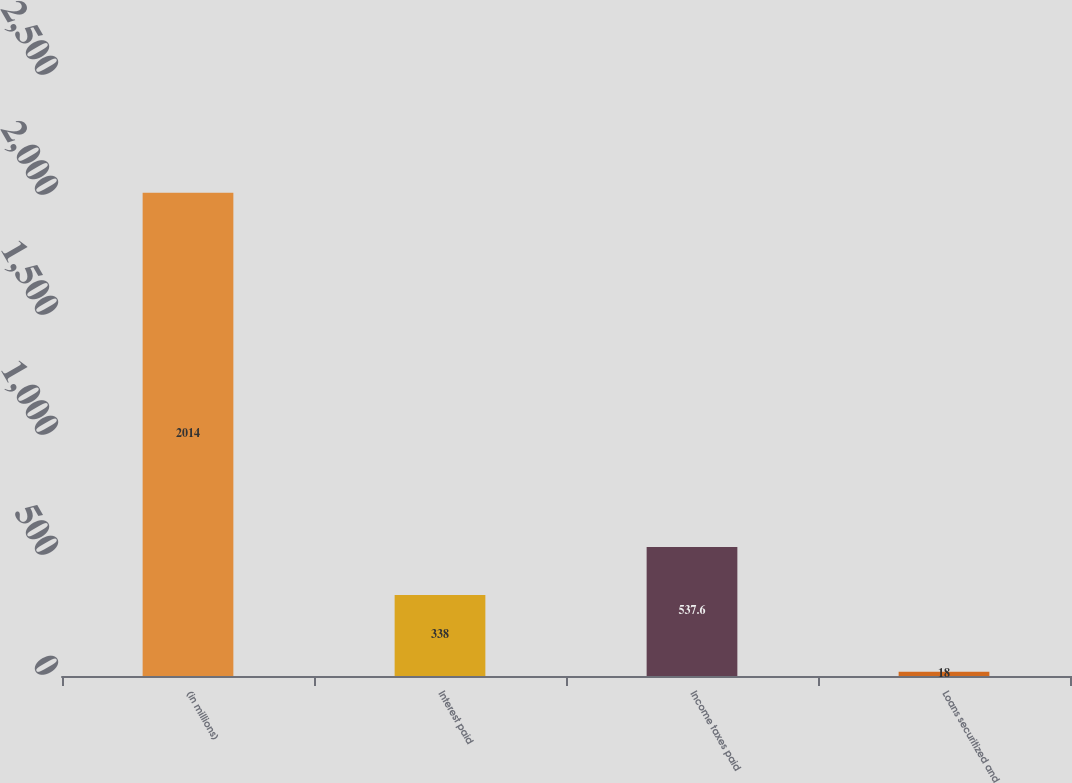Convert chart to OTSL. <chart><loc_0><loc_0><loc_500><loc_500><bar_chart><fcel>(in millions)<fcel>Interest paid<fcel>Income taxes paid<fcel>Loans securitized and<nl><fcel>2014<fcel>338<fcel>537.6<fcel>18<nl></chart> 